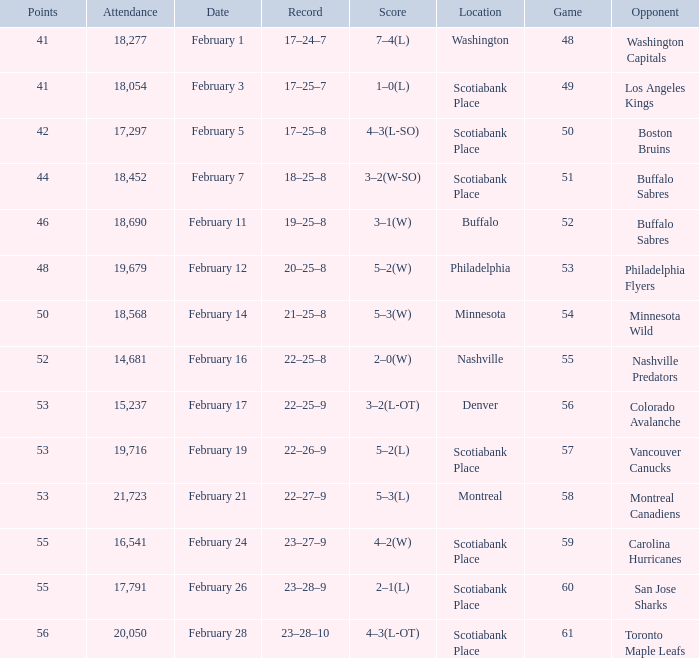What average game was held on february 24 and has an attendance smaller than 16,541? None. 